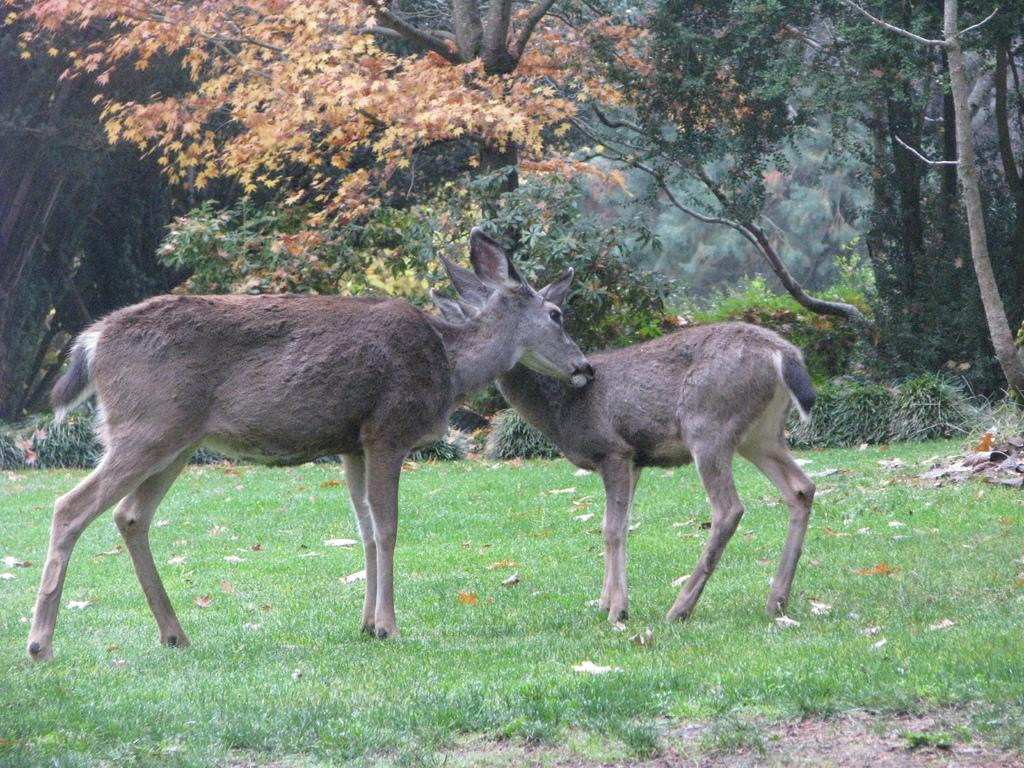What types of living organisms can be seen in the image? There are animals in the image. What is the position of the animals in relation to the ground? The animals are standing on the ground. What can be seen in the background of the image? There are trees and grass visible in the background of the image. Is there a volcano erupting in the background of the image? No, there is no volcano present in the image. What type of sponge can be seen being used by the animals in the image? There are no sponges visible in the image, and the animals are not using any sponges. 